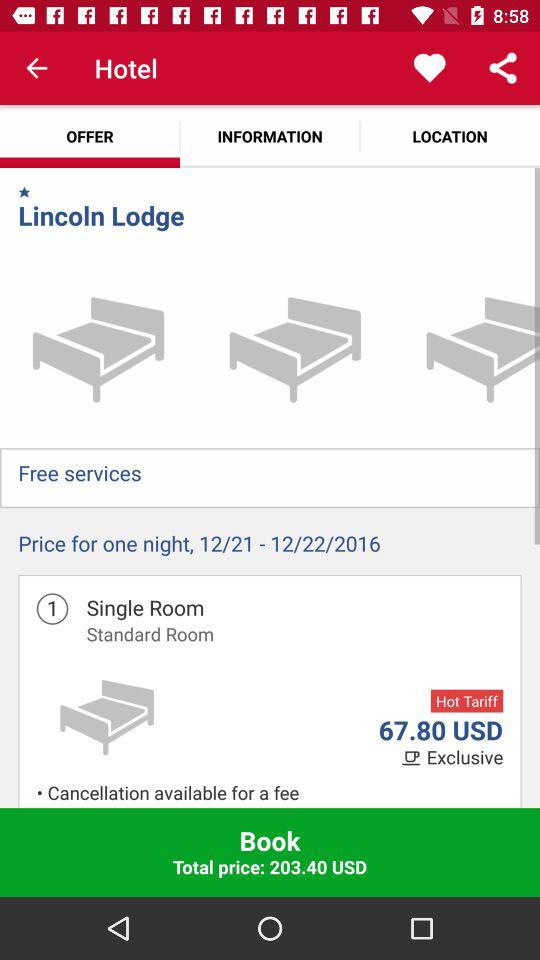What is the total price of the room?
Answer the question using a single word or phrase. 203.40 USD 